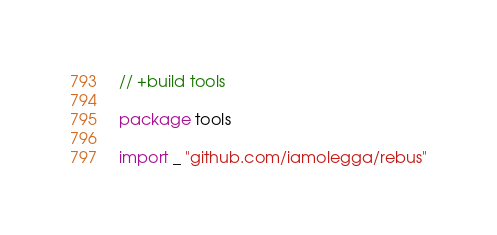<code> <loc_0><loc_0><loc_500><loc_500><_Go_>// +build tools

package tools

import _ "github.com/iamolegga/rebus"
</code> 